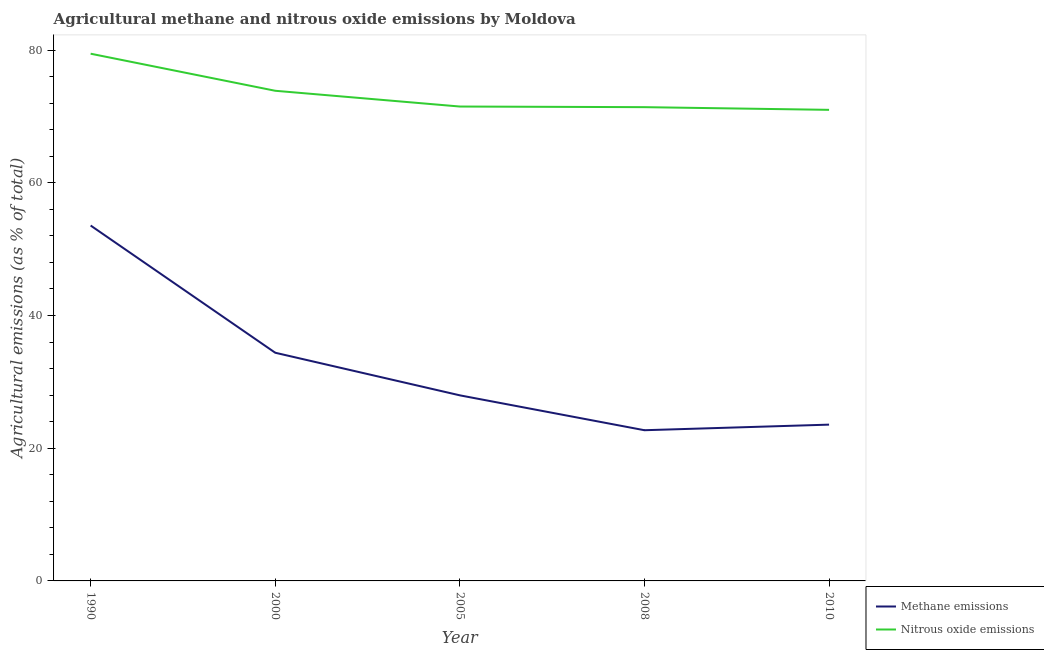Does the line corresponding to amount of methane emissions intersect with the line corresponding to amount of nitrous oxide emissions?
Give a very brief answer. No. What is the amount of nitrous oxide emissions in 2000?
Your response must be concise. 73.87. Across all years, what is the maximum amount of methane emissions?
Ensure brevity in your answer.  53.56. Across all years, what is the minimum amount of methane emissions?
Make the answer very short. 22.71. In which year was the amount of nitrous oxide emissions minimum?
Keep it short and to the point. 2010. What is the total amount of methane emissions in the graph?
Ensure brevity in your answer.  162.19. What is the difference between the amount of methane emissions in 2008 and that in 2010?
Your answer should be very brief. -0.84. What is the difference between the amount of methane emissions in 2010 and the amount of nitrous oxide emissions in 1990?
Ensure brevity in your answer.  -55.9. What is the average amount of nitrous oxide emissions per year?
Provide a succinct answer. 73.45. In the year 2000, what is the difference between the amount of methane emissions and amount of nitrous oxide emissions?
Offer a terse response. -39.48. In how many years, is the amount of methane emissions greater than 64 %?
Offer a terse response. 0. What is the ratio of the amount of methane emissions in 1990 to that in 2010?
Provide a succinct answer. 2.27. What is the difference between the highest and the second highest amount of nitrous oxide emissions?
Your answer should be very brief. 5.59. What is the difference between the highest and the lowest amount of methane emissions?
Provide a short and direct response. 30.85. In how many years, is the amount of nitrous oxide emissions greater than the average amount of nitrous oxide emissions taken over all years?
Your answer should be compact. 2. Is the sum of the amount of nitrous oxide emissions in 1990 and 2010 greater than the maximum amount of methane emissions across all years?
Offer a very short reply. Yes. Does the amount of methane emissions monotonically increase over the years?
Your answer should be compact. No. How many lines are there?
Give a very brief answer. 2. How many years are there in the graph?
Offer a very short reply. 5. Does the graph contain any zero values?
Offer a very short reply. No. Does the graph contain grids?
Keep it short and to the point. No. How many legend labels are there?
Ensure brevity in your answer.  2. How are the legend labels stacked?
Your answer should be compact. Vertical. What is the title of the graph?
Your answer should be very brief. Agricultural methane and nitrous oxide emissions by Moldova. What is the label or title of the Y-axis?
Your response must be concise. Agricultural emissions (as % of total). What is the Agricultural emissions (as % of total) of Methane emissions in 1990?
Your response must be concise. 53.56. What is the Agricultural emissions (as % of total) in Nitrous oxide emissions in 1990?
Your answer should be very brief. 79.46. What is the Agricultural emissions (as % of total) in Methane emissions in 2000?
Ensure brevity in your answer.  34.39. What is the Agricultural emissions (as % of total) in Nitrous oxide emissions in 2000?
Give a very brief answer. 73.87. What is the Agricultural emissions (as % of total) in Methane emissions in 2005?
Provide a succinct answer. 27.97. What is the Agricultural emissions (as % of total) in Nitrous oxide emissions in 2005?
Your answer should be compact. 71.5. What is the Agricultural emissions (as % of total) in Methane emissions in 2008?
Offer a terse response. 22.71. What is the Agricultural emissions (as % of total) of Nitrous oxide emissions in 2008?
Make the answer very short. 71.4. What is the Agricultural emissions (as % of total) in Methane emissions in 2010?
Make the answer very short. 23.55. What is the Agricultural emissions (as % of total) of Nitrous oxide emissions in 2010?
Provide a succinct answer. 71. Across all years, what is the maximum Agricultural emissions (as % of total) of Methane emissions?
Provide a short and direct response. 53.56. Across all years, what is the maximum Agricultural emissions (as % of total) of Nitrous oxide emissions?
Make the answer very short. 79.46. Across all years, what is the minimum Agricultural emissions (as % of total) of Methane emissions?
Your answer should be very brief. 22.71. Across all years, what is the minimum Agricultural emissions (as % of total) in Nitrous oxide emissions?
Provide a short and direct response. 71. What is the total Agricultural emissions (as % of total) in Methane emissions in the graph?
Your response must be concise. 162.19. What is the total Agricultural emissions (as % of total) in Nitrous oxide emissions in the graph?
Ensure brevity in your answer.  367.23. What is the difference between the Agricultural emissions (as % of total) of Methane emissions in 1990 and that in 2000?
Your answer should be very brief. 19.17. What is the difference between the Agricultural emissions (as % of total) in Nitrous oxide emissions in 1990 and that in 2000?
Offer a terse response. 5.59. What is the difference between the Agricultural emissions (as % of total) in Methane emissions in 1990 and that in 2005?
Offer a very short reply. 25.59. What is the difference between the Agricultural emissions (as % of total) in Nitrous oxide emissions in 1990 and that in 2005?
Your answer should be compact. 7.96. What is the difference between the Agricultural emissions (as % of total) of Methane emissions in 1990 and that in 2008?
Ensure brevity in your answer.  30.85. What is the difference between the Agricultural emissions (as % of total) in Nitrous oxide emissions in 1990 and that in 2008?
Give a very brief answer. 8.06. What is the difference between the Agricultural emissions (as % of total) of Methane emissions in 1990 and that in 2010?
Your answer should be compact. 30.01. What is the difference between the Agricultural emissions (as % of total) of Nitrous oxide emissions in 1990 and that in 2010?
Your answer should be compact. 8.46. What is the difference between the Agricultural emissions (as % of total) in Methane emissions in 2000 and that in 2005?
Your answer should be very brief. 6.42. What is the difference between the Agricultural emissions (as % of total) in Nitrous oxide emissions in 2000 and that in 2005?
Provide a succinct answer. 2.38. What is the difference between the Agricultural emissions (as % of total) of Methane emissions in 2000 and that in 2008?
Provide a short and direct response. 11.68. What is the difference between the Agricultural emissions (as % of total) of Nitrous oxide emissions in 2000 and that in 2008?
Offer a terse response. 2.47. What is the difference between the Agricultural emissions (as % of total) of Methane emissions in 2000 and that in 2010?
Keep it short and to the point. 10.84. What is the difference between the Agricultural emissions (as % of total) of Nitrous oxide emissions in 2000 and that in 2010?
Provide a short and direct response. 2.87. What is the difference between the Agricultural emissions (as % of total) in Methane emissions in 2005 and that in 2008?
Your answer should be very brief. 5.26. What is the difference between the Agricultural emissions (as % of total) of Nitrous oxide emissions in 2005 and that in 2008?
Provide a succinct answer. 0.09. What is the difference between the Agricultural emissions (as % of total) in Methane emissions in 2005 and that in 2010?
Your answer should be compact. 4.41. What is the difference between the Agricultural emissions (as % of total) of Nitrous oxide emissions in 2005 and that in 2010?
Provide a short and direct response. 0.5. What is the difference between the Agricultural emissions (as % of total) in Methane emissions in 2008 and that in 2010?
Provide a short and direct response. -0.84. What is the difference between the Agricultural emissions (as % of total) in Nitrous oxide emissions in 2008 and that in 2010?
Offer a terse response. 0.4. What is the difference between the Agricultural emissions (as % of total) in Methane emissions in 1990 and the Agricultural emissions (as % of total) in Nitrous oxide emissions in 2000?
Make the answer very short. -20.31. What is the difference between the Agricultural emissions (as % of total) in Methane emissions in 1990 and the Agricultural emissions (as % of total) in Nitrous oxide emissions in 2005?
Offer a terse response. -17.93. What is the difference between the Agricultural emissions (as % of total) in Methane emissions in 1990 and the Agricultural emissions (as % of total) in Nitrous oxide emissions in 2008?
Offer a very short reply. -17.84. What is the difference between the Agricultural emissions (as % of total) of Methane emissions in 1990 and the Agricultural emissions (as % of total) of Nitrous oxide emissions in 2010?
Your answer should be very brief. -17.44. What is the difference between the Agricultural emissions (as % of total) of Methane emissions in 2000 and the Agricultural emissions (as % of total) of Nitrous oxide emissions in 2005?
Provide a succinct answer. -37.11. What is the difference between the Agricultural emissions (as % of total) in Methane emissions in 2000 and the Agricultural emissions (as % of total) in Nitrous oxide emissions in 2008?
Your response must be concise. -37.01. What is the difference between the Agricultural emissions (as % of total) in Methane emissions in 2000 and the Agricultural emissions (as % of total) in Nitrous oxide emissions in 2010?
Your answer should be very brief. -36.61. What is the difference between the Agricultural emissions (as % of total) in Methane emissions in 2005 and the Agricultural emissions (as % of total) in Nitrous oxide emissions in 2008?
Provide a succinct answer. -43.43. What is the difference between the Agricultural emissions (as % of total) of Methane emissions in 2005 and the Agricultural emissions (as % of total) of Nitrous oxide emissions in 2010?
Make the answer very short. -43.03. What is the difference between the Agricultural emissions (as % of total) of Methane emissions in 2008 and the Agricultural emissions (as % of total) of Nitrous oxide emissions in 2010?
Give a very brief answer. -48.29. What is the average Agricultural emissions (as % of total) of Methane emissions per year?
Give a very brief answer. 32.44. What is the average Agricultural emissions (as % of total) in Nitrous oxide emissions per year?
Your answer should be compact. 73.45. In the year 1990, what is the difference between the Agricultural emissions (as % of total) of Methane emissions and Agricultural emissions (as % of total) of Nitrous oxide emissions?
Offer a very short reply. -25.9. In the year 2000, what is the difference between the Agricultural emissions (as % of total) in Methane emissions and Agricultural emissions (as % of total) in Nitrous oxide emissions?
Offer a very short reply. -39.48. In the year 2005, what is the difference between the Agricultural emissions (as % of total) of Methane emissions and Agricultural emissions (as % of total) of Nitrous oxide emissions?
Provide a short and direct response. -43.53. In the year 2008, what is the difference between the Agricultural emissions (as % of total) of Methane emissions and Agricultural emissions (as % of total) of Nitrous oxide emissions?
Give a very brief answer. -48.69. In the year 2010, what is the difference between the Agricultural emissions (as % of total) of Methane emissions and Agricultural emissions (as % of total) of Nitrous oxide emissions?
Make the answer very short. -47.44. What is the ratio of the Agricultural emissions (as % of total) in Methane emissions in 1990 to that in 2000?
Ensure brevity in your answer.  1.56. What is the ratio of the Agricultural emissions (as % of total) of Nitrous oxide emissions in 1990 to that in 2000?
Give a very brief answer. 1.08. What is the ratio of the Agricultural emissions (as % of total) in Methane emissions in 1990 to that in 2005?
Provide a short and direct response. 1.92. What is the ratio of the Agricultural emissions (as % of total) of Nitrous oxide emissions in 1990 to that in 2005?
Offer a very short reply. 1.11. What is the ratio of the Agricultural emissions (as % of total) of Methane emissions in 1990 to that in 2008?
Provide a succinct answer. 2.36. What is the ratio of the Agricultural emissions (as % of total) of Nitrous oxide emissions in 1990 to that in 2008?
Offer a terse response. 1.11. What is the ratio of the Agricultural emissions (as % of total) in Methane emissions in 1990 to that in 2010?
Your answer should be compact. 2.27. What is the ratio of the Agricultural emissions (as % of total) in Nitrous oxide emissions in 1990 to that in 2010?
Offer a terse response. 1.12. What is the ratio of the Agricultural emissions (as % of total) in Methane emissions in 2000 to that in 2005?
Provide a succinct answer. 1.23. What is the ratio of the Agricultural emissions (as % of total) of Nitrous oxide emissions in 2000 to that in 2005?
Give a very brief answer. 1.03. What is the ratio of the Agricultural emissions (as % of total) of Methane emissions in 2000 to that in 2008?
Make the answer very short. 1.51. What is the ratio of the Agricultural emissions (as % of total) in Nitrous oxide emissions in 2000 to that in 2008?
Provide a short and direct response. 1.03. What is the ratio of the Agricultural emissions (as % of total) in Methane emissions in 2000 to that in 2010?
Ensure brevity in your answer.  1.46. What is the ratio of the Agricultural emissions (as % of total) in Nitrous oxide emissions in 2000 to that in 2010?
Ensure brevity in your answer.  1.04. What is the ratio of the Agricultural emissions (as % of total) of Methane emissions in 2005 to that in 2008?
Provide a succinct answer. 1.23. What is the ratio of the Agricultural emissions (as % of total) in Nitrous oxide emissions in 2005 to that in 2008?
Give a very brief answer. 1. What is the ratio of the Agricultural emissions (as % of total) in Methane emissions in 2005 to that in 2010?
Ensure brevity in your answer.  1.19. What is the ratio of the Agricultural emissions (as % of total) in Methane emissions in 2008 to that in 2010?
Make the answer very short. 0.96. What is the difference between the highest and the second highest Agricultural emissions (as % of total) of Methane emissions?
Your response must be concise. 19.17. What is the difference between the highest and the second highest Agricultural emissions (as % of total) in Nitrous oxide emissions?
Make the answer very short. 5.59. What is the difference between the highest and the lowest Agricultural emissions (as % of total) of Methane emissions?
Your answer should be very brief. 30.85. What is the difference between the highest and the lowest Agricultural emissions (as % of total) in Nitrous oxide emissions?
Give a very brief answer. 8.46. 